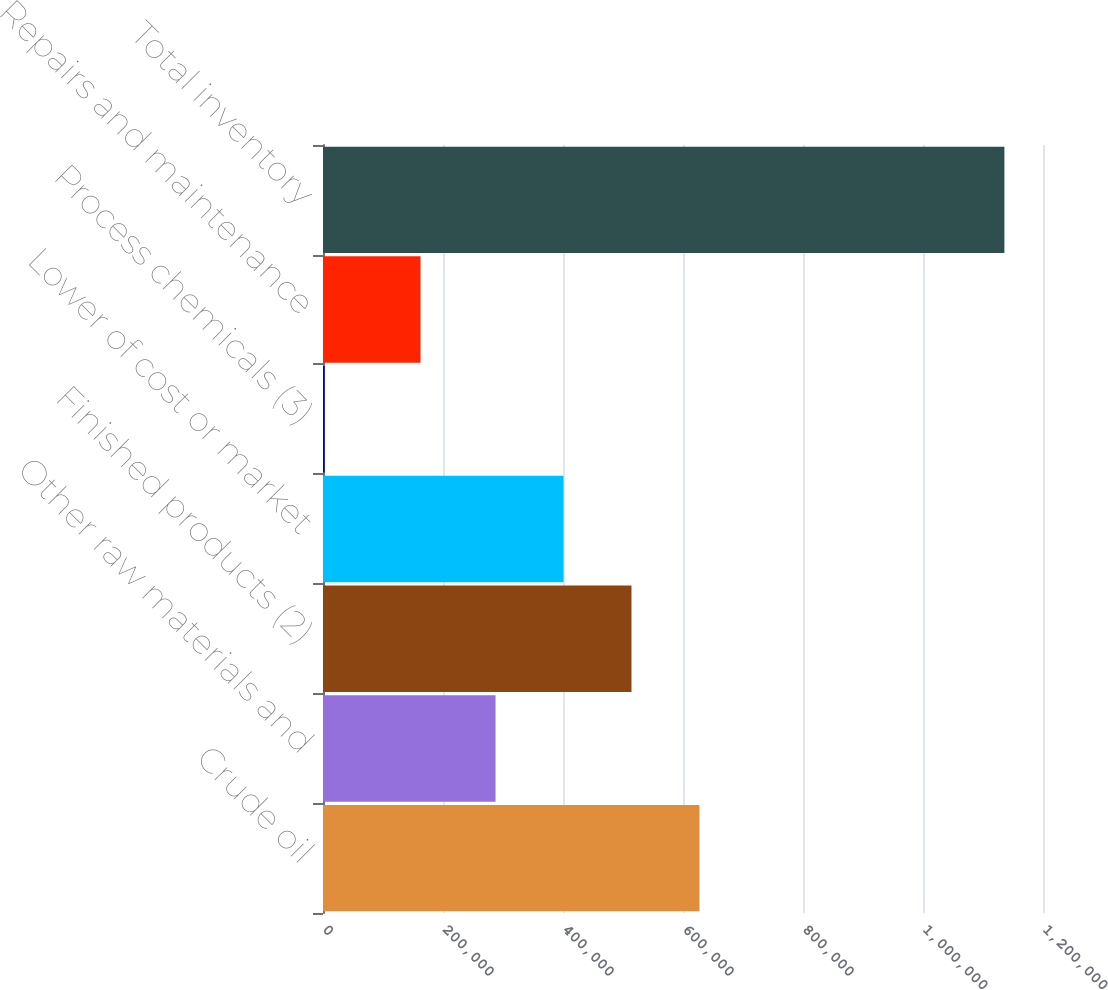Convert chart. <chart><loc_0><loc_0><loc_500><loc_500><bar_chart><fcel>Crude oil<fcel>Other raw materials and<fcel>Finished products (2)<fcel>Lower of cost or market<fcel>Process chemicals (3)<fcel>Repairs and maintenance<fcel>Total inventory<nl><fcel>627434<fcel>287561<fcel>514143<fcel>400852<fcel>2767<fcel>162548<fcel>1.13568e+06<nl></chart> 